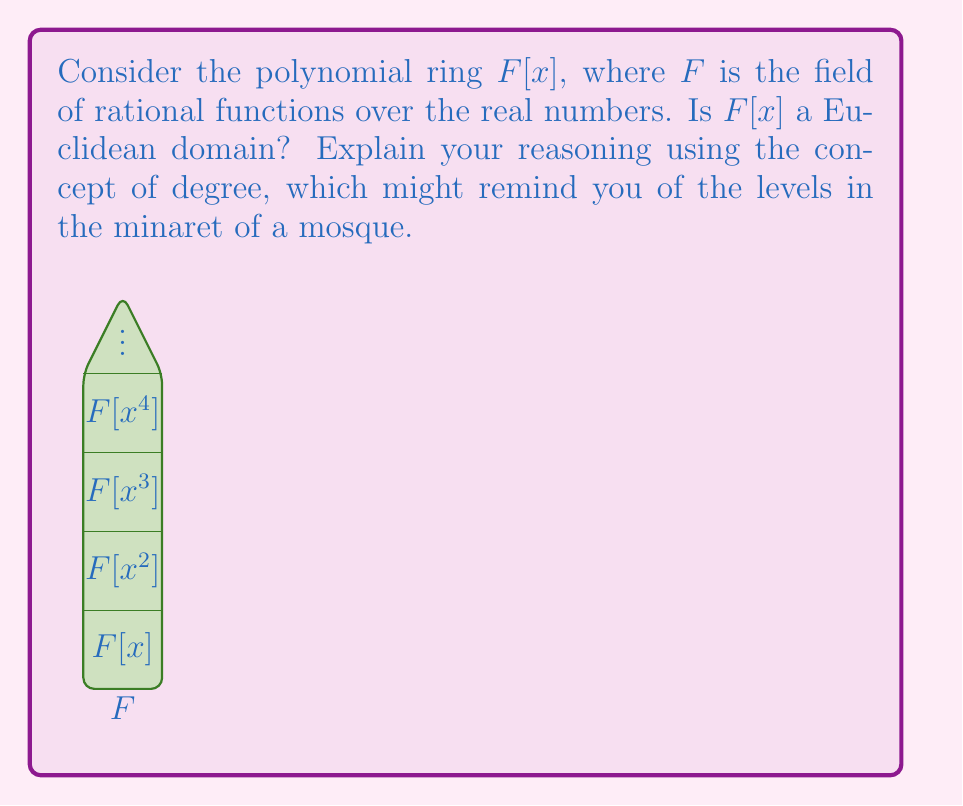Show me your answer to this math problem. To determine if $F[x]$ is a Euclidean domain, we need to check if it satisfies the properties of a Euclidean domain. The key property we'll focus on is the existence of a Euclidean function.

1) First, recall that a Euclidean domain is an integral domain $R$ with a function $d: R \setminus \{0\} \to \mathbb{N} \cup \{0\}$ satisfying certain properties.

2) For polynomial rings over a field, the degree of a polynomial can serve as this Euclidean function. Let's define $d(p(x)) = \deg(p(x))$ for non-zero polynomials in $F[x]$.

3) We need to verify two properties:
   a) For any $a,b \in F[x]$ with $b \neq 0$, there exist $q,r \in F[x]$ such that $a = bq + r$ with either $r = 0$ or $d(r) < d(b)$.
   b) For any $a,b \in F[x]$, $d(ab) \geq d(a)$.

4) Property (a) is satisfied by the polynomial division algorithm. We can always divide a polynomial by another non-zero polynomial to get a quotient and a remainder of lower degree.

5) Property (b) is satisfied because for polynomials, $\deg(ab) = \deg(a) + \deg(b) \geq \deg(a)$.

6) The field $F$ of rational functions over real numbers is indeed a field, as it contains all fractions of real polynomials.

7) Therefore, $F[x]$ satisfies all the properties of a Euclidean domain with the degree function as the Euclidean function.
Answer: Yes, $F[x]$ is a Euclidean domain. 